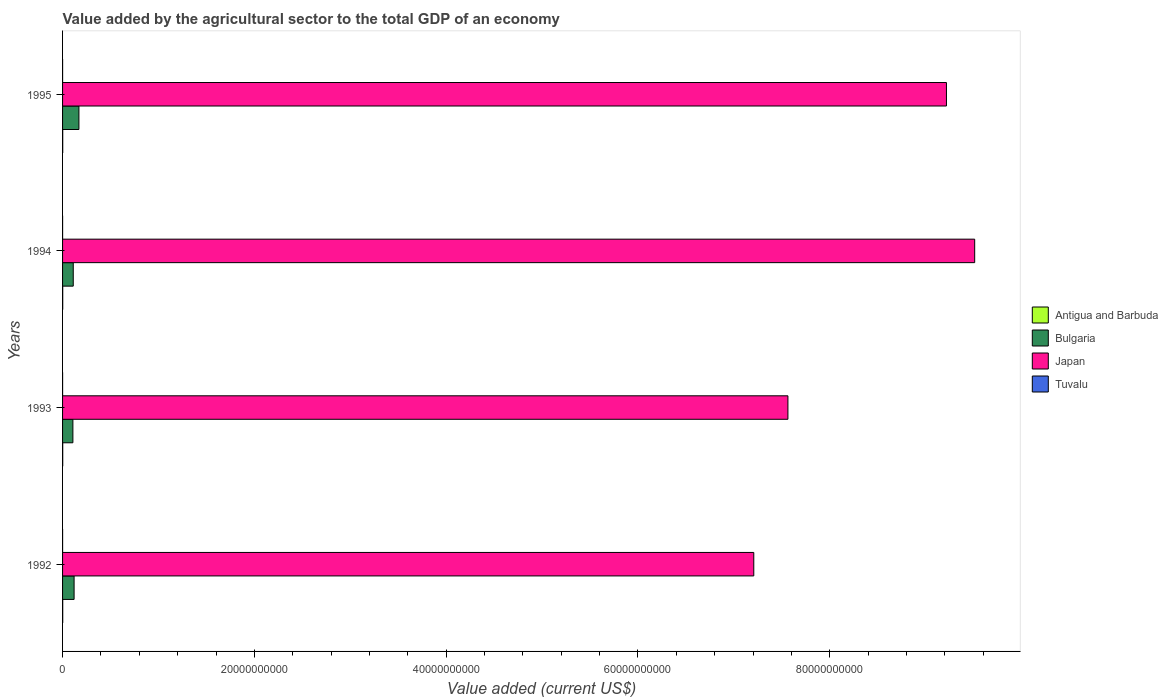How many different coloured bars are there?
Provide a succinct answer. 4. How many groups of bars are there?
Offer a very short reply. 4. How many bars are there on the 2nd tick from the bottom?
Your answer should be very brief. 4. What is the label of the 2nd group of bars from the top?
Your answer should be very brief. 1994. In how many cases, is the number of bars for a given year not equal to the number of legend labels?
Offer a very short reply. 0. What is the value added by the agricultural sector to the total GDP in Bulgaria in 1994?
Keep it short and to the point. 1.11e+09. Across all years, what is the maximum value added by the agricultural sector to the total GDP in Japan?
Your answer should be compact. 9.51e+1. Across all years, what is the minimum value added by the agricultural sector to the total GDP in Tuvalu?
Keep it short and to the point. 2.26e+06. In which year was the value added by the agricultural sector to the total GDP in Tuvalu maximum?
Provide a succinct answer. 1995. What is the total value added by the agricultural sector to the total GDP in Antigua and Barbuda in the graph?
Provide a short and direct response. 6.30e+07. What is the difference between the value added by the agricultural sector to the total GDP in Antigua and Barbuda in 1992 and that in 1993?
Give a very brief answer. -6.07e+05. What is the difference between the value added by the agricultural sector to the total GDP in Bulgaria in 1992 and the value added by the agricultural sector to the total GDP in Tuvalu in 1994?
Your answer should be very brief. 1.20e+09. What is the average value added by the agricultural sector to the total GDP in Bulgaria per year?
Your answer should be compact. 1.27e+09. In the year 1994, what is the difference between the value added by the agricultural sector to the total GDP in Tuvalu and value added by the agricultural sector to the total GDP in Bulgaria?
Offer a very short reply. -1.11e+09. What is the ratio of the value added by the agricultural sector to the total GDP in Antigua and Barbuda in 1992 to that in 1994?
Give a very brief answer. 0.97. Is the value added by the agricultural sector to the total GDP in Bulgaria in 1994 less than that in 1995?
Provide a short and direct response. Yes. What is the difference between the highest and the second highest value added by the agricultural sector to the total GDP in Japan?
Offer a very short reply. 2.94e+09. What is the difference between the highest and the lowest value added by the agricultural sector to the total GDP in Antigua and Barbuda?
Keep it short and to the point. 8.37e+05. Is the sum of the value added by the agricultural sector to the total GDP in Bulgaria in 1993 and 1995 greater than the maximum value added by the agricultural sector to the total GDP in Antigua and Barbuda across all years?
Give a very brief answer. Yes. What does the 1st bar from the top in 1994 represents?
Give a very brief answer. Tuvalu. What does the 3rd bar from the bottom in 1993 represents?
Your response must be concise. Japan. What is the difference between two consecutive major ticks on the X-axis?
Offer a terse response. 2.00e+1. Does the graph contain grids?
Offer a very short reply. No. What is the title of the graph?
Your answer should be very brief. Value added by the agricultural sector to the total GDP of an economy. What is the label or title of the X-axis?
Keep it short and to the point. Value added (current US$). What is the label or title of the Y-axis?
Keep it short and to the point. Years. What is the Value added (current US$) in Antigua and Barbuda in 1992?
Keep it short and to the point. 1.53e+07. What is the Value added (current US$) in Bulgaria in 1992?
Provide a succinct answer. 1.20e+09. What is the Value added (current US$) in Japan in 1992?
Provide a succinct answer. 7.21e+1. What is the Value added (current US$) in Tuvalu in 1992?
Your answer should be compact. 2.26e+06. What is the Value added (current US$) of Antigua and Barbuda in 1993?
Your response must be concise. 1.59e+07. What is the Value added (current US$) in Bulgaria in 1993?
Your answer should be very brief. 1.08e+09. What is the Value added (current US$) in Japan in 1993?
Offer a very short reply. 7.56e+1. What is the Value added (current US$) in Tuvalu in 1993?
Make the answer very short. 2.27e+06. What is the Value added (current US$) of Antigua and Barbuda in 1994?
Give a very brief answer. 1.58e+07. What is the Value added (current US$) of Bulgaria in 1994?
Give a very brief answer. 1.11e+09. What is the Value added (current US$) in Japan in 1994?
Offer a very short reply. 9.51e+1. What is the Value added (current US$) of Tuvalu in 1994?
Make the answer very short. 2.57e+06. What is the Value added (current US$) in Antigua and Barbuda in 1995?
Your answer should be compact. 1.61e+07. What is the Value added (current US$) in Bulgaria in 1995?
Your response must be concise. 1.71e+09. What is the Value added (current US$) of Japan in 1995?
Provide a short and direct response. 9.22e+1. What is the Value added (current US$) of Tuvalu in 1995?
Make the answer very short. 2.65e+06. Across all years, what is the maximum Value added (current US$) in Antigua and Barbuda?
Your answer should be compact. 1.61e+07. Across all years, what is the maximum Value added (current US$) in Bulgaria?
Offer a terse response. 1.71e+09. Across all years, what is the maximum Value added (current US$) in Japan?
Your response must be concise. 9.51e+1. Across all years, what is the maximum Value added (current US$) of Tuvalu?
Your response must be concise. 2.65e+06. Across all years, what is the minimum Value added (current US$) of Antigua and Barbuda?
Give a very brief answer. 1.53e+07. Across all years, what is the minimum Value added (current US$) in Bulgaria?
Your answer should be compact. 1.08e+09. Across all years, what is the minimum Value added (current US$) in Japan?
Make the answer very short. 7.21e+1. Across all years, what is the minimum Value added (current US$) of Tuvalu?
Provide a short and direct response. 2.26e+06. What is the total Value added (current US$) of Antigua and Barbuda in the graph?
Make the answer very short. 6.30e+07. What is the total Value added (current US$) in Bulgaria in the graph?
Make the answer very short. 5.10e+09. What is the total Value added (current US$) of Japan in the graph?
Offer a terse response. 3.35e+11. What is the total Value added (current US$) in Tuvalu in the graph?
Make the answer very short. 9.75e+06. What is the difference between the Value added (current US$) in Antigua and Barbuda in 1992 and that in 1993?
Provide a succinct answer. -6.07e+05. What is the difference between the Value added (current US$) of Bulgaria in 1992 and that in 1993?
Keep it short and to the point. 1.27e+08. What is the difference between the Value added (current US$) of Japan in 1992 and that in 1993?
Give a very brief answer. -3.56e+09. What is the difference between the Value added (current US$) in Tuvalu in 1992 and that in 1993?
Your answer should be very brief. -1.37e+04. What is the difference between the Value added (current US$) of Antigua and Barbuda in 1992 and that in 1994?
Your answer should be very brief. -5.30e+05. What is the difference between the Value added (current US$) of Bulgaria in 1992 and that in 1994?
Give a very brief answer. 8.81e+07. What is the difference between the Value added (current US$) of Japan in 1992 and that in 1994?
Provide a succinct answer. -2.30e+1. What is the difference between the Value added (current US$) in Tuvalu in 1992 and that in 1994?
Offer a terse response. -3.11e+05. What is the difference between the Value added (current US$) of Antigua and Barbuda in 1992 and that in 1995?
Your response must be concise. -8.37e+05. What is the difference between the Value added (current US$) of Bulgaria in 1992 and that in 1995?
Give a very brief answer. -5.03e+08. What is the difference between the Value added (current US$) in Japan in 1992 and that in 1995?
Your response must be concise. -2.01e+1. What is the difference between the Value added (current US$) in Tuvalu in 1992 and that in 1995?
Give a very brief answer. -3.94e+05. What is the difference between the Value added (current US$) in Antigua and Barbuda in 1993 and that in 1994?
Offer a very short reply. 7.78e+04. What is the difference between the Value added (current US$) of Bulgaria in 1993 and that in 1994?
Make the answer very short. -3.85e+07. What is the difference between the Value added (current US$) of Japan in 1993 and that in 1994?
Make the answer very short. -1.95e+1. What is the difference between the Value added (current US$) of Tuvalu in 1993 and that in 1994?
Offer a terse response. -2.97e+05. What is the difference between the Value added (current US$) of Antigua and Barbuda in 1993 and that in 1995?
Your answer should be very brief. -2.30e+05. What is the difference between the Value added (current US$) of Bulgaria in 1993 and that in 1995?
Offer a very short reply. -6.30e+08. What is the difference between the Value added (current US$) in Japan in 1993 and that in 1995?
Your answer should be compact. -1.65e+1. What is the difference between the Value added (current US$) of Tuvalu in 1993 and that in 1995?
Ensure brevity in your answer.  -3.80e+05. What is the difference between the Value added (current US$) in Antigua and Barbuda in 1994 and that in 1995?
Offer a terse response. -3.07e+05. What is the difference between the Value added (current US$) of Bulgaria in 1994 and that in 1995?
Your response must be concise. -5.92e+08. What is the difference between the Value added (current US$) of Japan in 1994 and that in 1995?
Give a very brief answer. 2.94e+09. What is the difference between the Value added (current US$) of Tuvalu in 1994 and that in 1995?
Ensure brevity in your answer.  -8.31e+04. What is the difference between the Value added (current US$) of Antigua and Barbuda in 1992 and the Value added (current US$) of Bulgaria in 1993?
Keep it short and to the point. -1.06e+09. What is the difference between the Value added (current US$) in Antigua and Barbuda in 1992 and the Value added (current US$) in Japan in 1993?
Make the answer very short. -7.56e+1. What is the difference between the Value added (current US$) of Antigua and Barbuda in 1992 and the Value added (current US$) of Tuvalu in 1993?
Ensure brevity in your answer.  1.30e+07. What is the difference between the Value added (current US$) in Bulgaria in 1992 and the Value added (current US$) in Japan in 1993?
Keep it short and to the point. -7.44e+1. What is the difference between the Value added (current US$) of Bulgaria in 1992 and the Value added (current US$) of Tuvalu in 1993?
Your answer should be very brief. 1.20e+09. What is the difference between the Value added (current US$) in Japan in 1992 and the Value added (current US$) in Tuvalu in 1993?
Your response must be concise. 7.21e+1. What is the difference between the Value added (current US$) in Antigua and Barbuda in 1992 and the Value added (current US$) in Bulgaria in 1994?
Your answer should be compact. -1.10e+09. What is the difference between the Value added (current US$) in Antigua and Barbuda in 1992 and the Value added (current US$) in Japan in 1994?
Offer a very short reply. -9.51e+1. What is the difference between the Value added (current US$) in Antigua and Barbuda in 1992 and the Value added (current US$) in Tuvalu in 1994?
Give a very brief answer. 1.27e+07. What is the difference between the Value added (current US$) of Bulgaria in 1992 and the Value added (current US$) of Japan in 1994?
Provide a short and direct response. -9.39e+1. What is the difference between the Value added (current US$) in Bulgaria in 1992 and the Value added (current US$) in Tuvalu in 1994?
Ensure brevity in your answer.  1.20e+09. What is the difference between the Value added (current US$) in Japan in 1992 and the Value added (current US$) in Tuvalu in 1994?
Your answer should be compact. 7.21e+1. What is the difference between the Value added (current US$) of Antigua and Barbuda in 1992 and the Value added (current US$) of Bulgaria in 1995?
Your answer should be compact. -1.69e+09. What is the difference between the Value added (current US$) in Antigua and Barbuda in 1992 and the Value added (current US$) in Japan in 1995?
Offer a terse response. -9.22e+1. What is the difference between the Value added (current US$) in Antigua and Barbuda in 1992 and the Value added (current US$) in Tuvalu in 1995?
Keep it short and to the point. 1.26e+07. What is the difference between the Value added (current US$) in Bulgaria in 1992 and the Value added (current US$) in Japan in 1995?
Give a very brief answer. -9.10e+1. What is the difference between the Value added (current US$) of Bulgaria in 1992 and the Value added (current US$) of Tuvalu in 1995?
Provide a succinct answer. 1.20e+09. What is the difference between the Value added (current US$) in Japan in 1992 and the Value added (current US$) in Tuvalu in 1995?
Provide a short and direct response. 7.21e+1. What is the difference between the Value added (current US$) of Antigua and Barbuda in 1993 and the Value added (current US$) of Bulgaria in 1994?
Your answer should be very brief. -1.10e+09. What is the difference between the Value added (current US$) in Antigua and Barbuda in 1993 and the Value added (current US$) in Japan in 1994?
Make the answer very short. -9.51e+1. What is the difference between the Value added (current US$) of Antigua and Barbuda in 1993 and the Value added (current US$) of Tuvalu in 1994?
Ensure brevity in your answer.  1.33e+07. What is the difference between the Value added (current US$) of Bulgaria in 1993 and the Value added (current US$) of Japan in 1994?
Keep it short and to the point. -9.40e+1. What is the difference between the Value added (current US$) in Bulgaria in 1993 and the Value added (current US$) in Tuvalu in 1994?
Keep it short and to the point. 1.07e+09. What is the difference between the Value added (current US$) of Japan in 1993 and the Value added (current US$) of Tuvalu in 1994?
Your response must be concise. 7.56e+1. What is the difference between the Value added (current US$) in Antigua and Barbuda in 1993 and the Value added (current US$) in Bulgaria in 1995?
Give a very brief answer. -1.69e+09. What is the difference between the Value added (current US$) in Antigua and Barbuda in 1993 and the Value added (current US$) in Japan in 1995?
Make the answer very short. -9.22e+1. What is the difference between the Value added (current US$) of Antigua and Barbuda in 1993 and the Value added (current US$) of Tuvalu in 1995?
Your response must be concise. 1.32e+07. What is the difference between the Value added (current US$) of Bulgaria in 1993 and the Value added (current US$) of Japan in 1995?
Ensure brevity in your answer.  -9.11e+1. What is the difference between the Value added (current US$) in Bulgaria in 1993 and the Value added (current US$) in Tuvalu in 1995?
Keep it short and to the point. 1.07e+09. What is the difference between the Value added (current US$) in Japan in 1993 and the Value added (current US$) in Tuvalu in 1995?
Your answer should be very brief. 7.56e+1. What is the difference between the Value added (current US$) in Antigua and Barbuda in 1994 and the Value added (current US$) in Bulgaria in 1995?
Ensure brevity in your answer.  -1.69e+09. What is the difference between the Value added (current US$) in Antigua and Barbuda in 1994 and the Value added (current US$) in Japan in 1995?
Ensure brevity in your answer.  -9.22e+1. What is the difference between the Value added (current US$) of Antigua and Barbuda in 1994 and the Value added (current US$) of Tuvalu in 1995?
Your answer should be very brief. 1.31e+07. What is the difference between the Value added (current US$) in Bulgaria in 1994 and the Value added (current US$) in Japan in 1995?
Your answer should be very brief. -9.11e+1. What is the difference between the Value added (current US$) of Bulgaria in 1994 and the Value added (current US$) of Tuvalu in 1995?
Keep it short and to the point. 1.11e+09. What is the difference between the Value added (current US$) of Japan in 1994 and the Value added (current US$) of Tuvalu in 1995?
Your answer should be very brief. 9.51e+1. What is the average Value added (current US$) of Antigua and Barbuda per year?
Your response must be concise. 1.57e+07. What is the average Value added (current US$) of Bulgaria per year?
Offer a terse response. 1.27e+09. What is the average Value added (current US$) of Japan per year?
Your answer should be compact. 8.38e+1. What is the average Value added (current US$) of Tuvalu per year?
Make the answer very short. 2.44e+06. In the year 1992, what is the difference between the Value added (current US$) of Antigua and Barbuda and Value added (current US$) of Bulgaria?
Offer a very short reply. -1.19e+09. In the year 1992, what is the difference between the Value added (current US$) in Antigua and Barbuda and Value added (current US$) in Japan?
Keep it short and to the point. -7.21e+1. In the year 1992, what is the difference between the Value added (current US$) of Antigua and Barbuda and Value added (current US$) of Tuvalu?
Your response must be concise. 1.30e+07. In the year 1992, what is the difference between the Value added (current US$) of Bulgaria and Value added (current US$) of Japan?
Offer a very short reply. -7.09e+1. In the year 1992, what is the difference between the Value added (current US$) in Bulgaria and Value added (current US$) in Tuvalu?
Make the answer very short. 1.20e+09. In the year 1992, what is the difference between the Value added (current US$) of Japan and Value added (current US$) of Tuvalu?
Keep it short and to the point. 7.21e+1. In the year 1993, what is the difference between the Value added (current US$) of Antigua and Barbuda and Value added (current US$) of Bulgaria?
Make the answer very short. -1.06e+09. In the year 1993, what is the difference between the Value added (current US$) in Antigua and Barbuda and Value added (current US$) in Japan?
Offer a very short reply. -7.56e+1. In the year 1993, what is the difference between the Value added (current US$) of Antigua and Barbuda and Value added (current US$) of Tuvalu?
Offer a terse response. 1.36e+07. In the year 1993, what is the difference between the Value added (current US$) of Bulgaria and Value added (current US$) of Japan?
Keep it short and to the point. -7.46e+1. In the year 1993, what is the difference between the Value added (current US$) in Bulgaria and Value added (current US$) in Tuvalu?
Offer a terse response. 1.07e+09. In the year 1993, what is the difference between the Value added (current US$) of Japan and Value added (current US$) of Tuvalu?
Your answer should be very brief. 7.56e+1. In the year 1994, what is the difference between the Value added (current US$) in Antigua and Barbuda and Value added (current US$) in Bulgaria?
Give a very brief answer. -1.10e+09. In the year 1994, what is the difference between the Value added (current US$) in Antigua and Barbuda and Value added (current US$) in Japan?
Keep it short and to the point. -9.51e+1. In the year 1994, what is the difference between the Value added (current US$) in Antigua and Barbuda and Value added (current US$) in Tuvalu?
Provide a short and direct response. 1.32e+07. In the year 1994, what is the difference between the Value added (current US$) in Bulgaria and Value added (current US$) in Japan?
Provide a short and direct response. -9.40e+1. In the year 1994, what is the difference between the Value added (current US$) of Bulgaria and Value added (current US$) of Tuvalu?
Offer a terse response. 1.11e+09. In the year 1994, what is the difference between the Value added (current US$) of Japan and Value added (current US$) of Tuvalu?
Your answer should be compact. 9.51e+1. In the year 1995, what is the difference between the Value added (current US$) of Antigua and Barbuda and Value added (current US$) of Bulgaria?
Make the answer very short. -1.69e+09. In the year 1995, what is the difference between the Value added (current US$) in Antigua and Barbuda and Value added (current US$) in Japan?
Provide a succinct answer. -9.22e+1. In the year 1995, what is the difference between the Value added (current US$) in Antigua and Barbuda and Value added (current US$) in Tuvalu?
Your answer should be compact. 1.34e+07. In the year 1995, what is the difference between the Value added (current US$) in Bulgaria and Value added (current US$) in Japan?
Keep it short and to the point. -9.05e+1. In the year 1995, what is the difference between the Value added (current US$) in Bulgaria and Value added (current US$) in Tuvalu?
Offer a very short reply. 1.70e+09. In the year 1995, what is the difference between the Value added (current US$) of Japan and Value added (current US$) of Tuvalu?
Your answer should be compact. 9.22e+1. What is the ratio of the Value added (current US$) of Antigua and Barbuda in 1992 to that in 1993?
Give a very brief answer. 0.96. What is the ratio of the Value added (current US$) of Bulgaria in 1992 to that in 1993?
Your answer should be very brief. 1.12. What is the ratio of the Value added (current US$) of Japan in 1992 to that in 1993?
Keep it short and to the point. 0.95. What is the ratio of the Value added (current US$) in Tuvalu in 1992 to that in 1993?
Keep it short and to the point. 0.99. What is the ratio of the Value added (current US$) in Antigua and Barbuda in 1992 to that in 1994?
Give a very brief answer. 0.97. What is the ratio of the Value added (current US$) in Bulgaria in 1992 to that in 1994?
Offer a very short reply. 1.08. What is the ratio of the Value added (current US$) in Japan in 1992 to that in 1994?
Make the answer very short. 0.76. What is the ratio of the Value added (current US$) in Tuvalu in 1992 to that in 1994?
Offer a very short reply. 0.88. What is the ratio of the Value added (current US$) of Antigua and Barbuda in 1992 to that in 1995?
Give a very brief answer. 0.95. What is the ratio of the Value added (current US$) of Bulgaria in 1992 to that in 1995?
Offer a very short reply. 0.7. What is the ratio of the Value added (current US$) of Japan in 1992 to that in 1995?
Your answer should be compact. 0.78. What is the ratio of the Value added (current US$) of Tuvalu in 1992 to that in 1995?
Your answer should be very brief. 0.85. What is the ratio of the Value added (current US$) of Antigua and Barbuda in 1993 to that in 1994?
Offer a terse response. 1. What is the ratio of the Value added (current US$) of Bulgaria in 1993 to that in 1994?
Your answer should be very brief. 0.97. What is the ratio of the Value added (current US$) of Japan in 1993 to that in 1994?
Give a very brief answer. 0.8. What is the ratio of the Value added (current US$) of Tuvalu in 1993 to that in 1994?
Your answer should be very brief. 0.88. What is the ratio of the Value added (current US$) in Antigua and Barbuda in 1993 to that in 1995?
Your answer should be compact. 0.99. What is the ratio of the Value added (current US$) in Bulgaria in 1993 to that in 1995?
Your response must be concise. 0.63. What is the ratio of the Value added (current US$) in Japan in 1993 to that in 1995?
Offer a terse response. 0.82. What is the ratio of the Value added (current US$) in Tuvalu in 1993 to that in 1995?
Your answer should be very brief. 0.86. What is the ratio of the Value added (current US$) of Antigua and Barbuda in 1994 to that in 1995?
Give a very brief answer. 0.98. What is the ratio of the Value added (current US$) in Bulgaria in 1994 to that in 1995?
Offer a terse response. 0.65. What is the ratio of the Value added (current US$) of Japan in 1994 to that in 1995?
Make the answer very short. 1.03. What is the ratio of the Value added (current US$) in Tuvalu in 1994 to that in 1995?
Make the answer very short. 0.97. What is the difference between the highest and the second highest Value added (current US$) of Antigua and Barbuda?
Provide a succinct answer. 2.30e+05. What is the difference between the highest and the second highest Value added (current US$) of Bulgaria?
Provide a short and direct response. 5.03e+08. What is the difference between the highest and the second highest Value added (current US$) in Japan?
Your answer should be compact. 2.94e+09. What is the difference between the highest and the second highest Value added (current US$) of Tuvalu?
Give a very brief answer. 8.31e+04. What is the difference between the highest and the lowest Value added (current US$) in Antigua and Barbuda?
Provide a short and direct response. 8.37e+05. What is the difference between the highest and the lowest Value added (current US$) in Bulgaria?
Keep it short and to the point. 6.30e+08. What is the difference between the highest and the lowest Value added (current US$) of Japan?
Your answer should be very brief. 2.30e+1. What is the difference between the highest and the lowest Value added (current US$) of Tuvalu?
Offer a terse response. 3.94e+05. 